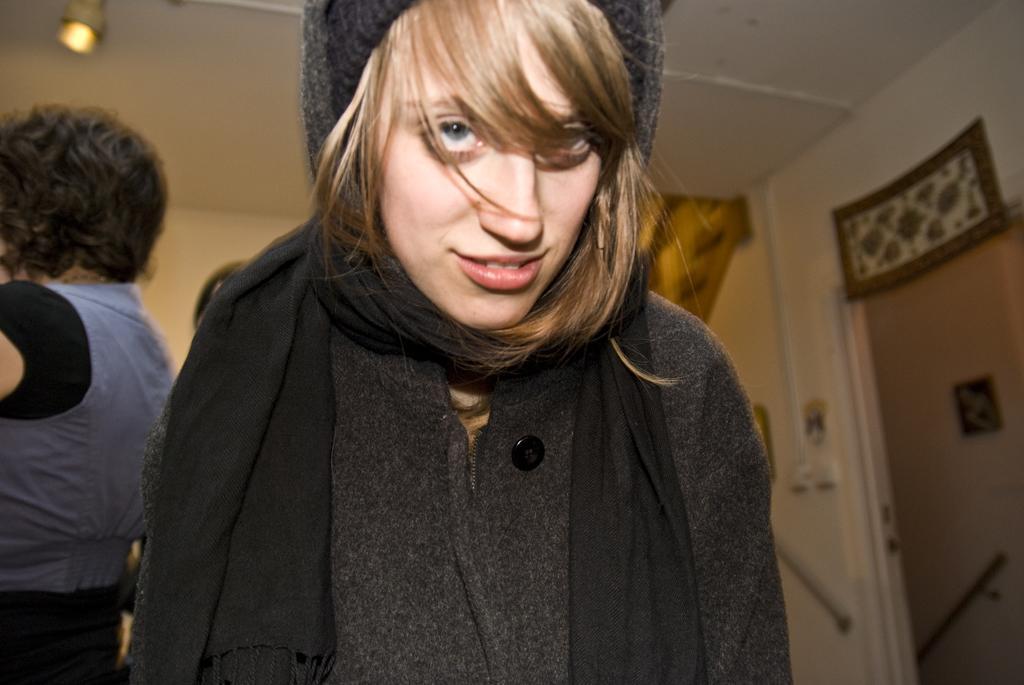In one or two sentences, can you explain what this image depicts? In this image I can see a woman in the front, wearing a black dress. There is another person on the left. There is a light at the top and a door on the right. 